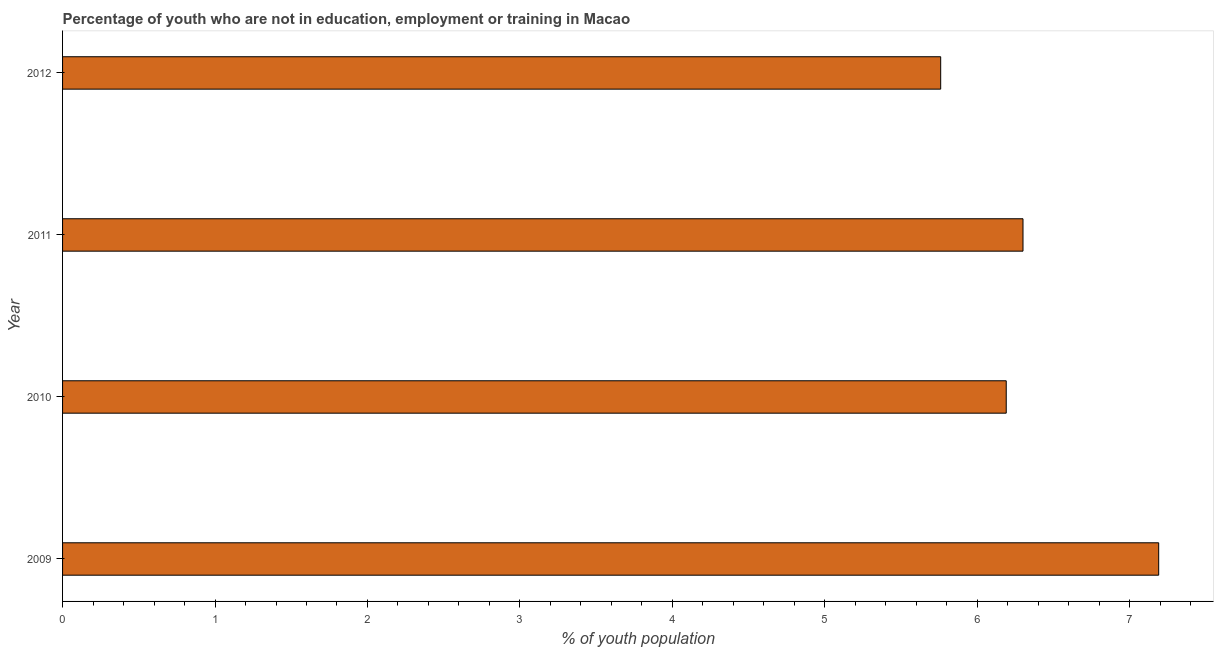Does the graph contain grids?
Make the answer very short. No. What is the title of the graph?
Your response must be concise. Percentage of youth who are not in education, employment or training in Macao. What is the label or title of the X-axis?
Keep it short and to the point. % of youth population. What is the unemployed youth population in 2011?
Ensure brevity in your answer.  6.3. Across all years, what is the maximum unemployed youth population?
Provide a succinct answer. 7.19. Across all years, what is the minimum unemployed youth population?
Ensure brevity in your answer.  5.76. In which year was the unemployed youth population minimum?
Give a very brief answer. 2012. What is the sum of the unemployed youth population?
Your response must be concise. 25.44. What is the difference between the unemployed youth population in 2009 and 2010?
Provide a succinct answer. 1. What is the average unemployed youth population per year?
Your response must be concise. 6.36. What is the median unemployed youth population?
Provide a short and direct response. 6.25. In how many years, is the unemployed youth population greater than 6.2 %?
Offer a very short reply. 2. Do a majority of the years between 2009 and 2010 (inclusive) have unemployed youth population greater than 4.6 %?
Ensure brevity in your answer.  Yes. What is the ratio of the unemployed youth population in 2011 to that in 2012?
Your answer should be very brief. 1.09. Is the difference between the unemployed youth population in 2009 and 2010 greater than the difference between any two years?
Your answer should be compact. No. What is the difference between the highest and the second highest unemployed youth population?
Your answer should be very brief. 0.89. What is the difference between the highest and the lowest unemployed youth population?
Your answer should be very brief. 1.43. In how many years, is the unemployed youth population greater than the average unemployed youth population taken over all years?
Make the answer very short. 1. How many years are there in the graph?
Your answer should be very brief. 4. What is the difference between two consecutive major ticks on the X-axis?
Your response must be concise. 1. Are the values on the major ticks of X-axis written in scientific E-notation?
Provide a succinct answer. No. What is the % of youth population of 2009?
Your answer should be very brief. 7.19. What is the % of youth population of 2010?
Make the answer very short. 6.19. What is the % of youth population in 2011?
Offer a terse response. 6.3. What is the % of youth population in 2012?
Provide a succinct answer. 5.76. What is the difference between the % of youth population in 2009 and 2011?
Make the answer very short. 0.89. What is the difference between the % of youth population in 2009 and 2012?
Provide a short and direct response. 1.43. What is the difference between the % of youth population in 2010 and 2011?
Your response must be concise. -0.11. What is the difference between the % of youth population in 2010 and 2012?
Give a very brief answer. 0.43. What is the difference between the % of youth population in 2011 and 2012?
Provide a succinct answer. 0.54. What is the ratio of the % of youth population in 2009 to that in 2010?
Offer a terse response. 1.16. What is the ratio of the % of youth population in 2009 to that in 2011?
Ensure brevity in your answer.  1.14. What is the ratio of the % of youth population in 2009 to that in 2012?
Keep it short and to the point. 1.25. What is the ratio of the % of youth population in 2010 to that in 2011?
Provide a succinct answer. 0.98. What is the ratio of the % of youth population in 2010 to that in 2012?
Make the answer very short. 1.07. What is the ratio of the % of youth population in 2011 to that in 2012?
Ensure brevity in your answer.  1.09. 